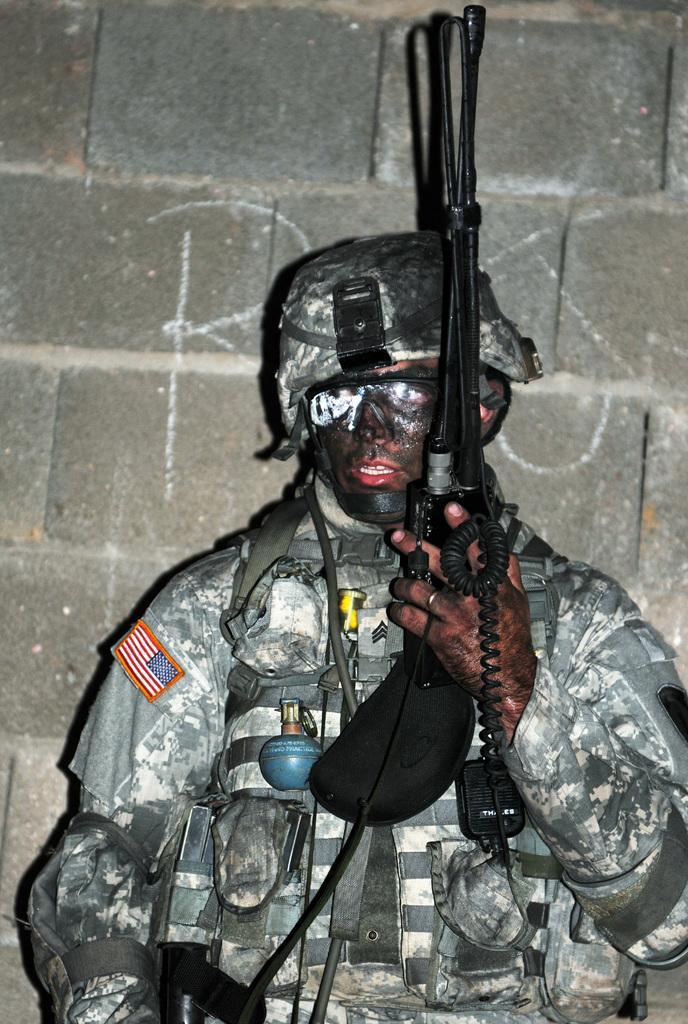In one or two sentences, can you explain what this image depicts? In this picture I can see a person holding an object, and in the background there is a wall. 